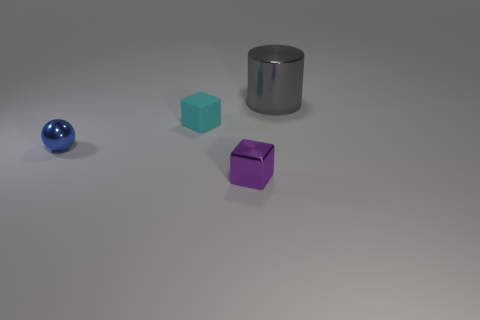Add 3 red things. How many objects exist? 7 Subtract 1 cubes. How many cubes are left? 1 Subtract all cyan cubes. How many cubes are left? 1 Subtract 0 purple spheres. How many objects are left? 4 Subtract all cylinders. How many objects are left? 3 Subtract all cyan blocks. Subtract all cyan spheres. How many blocks are left? 1 Subtract all cyan cylinders. How many cyan blocks are left? 1 Subtract all gray metallic cylinders. Subtract all small metal things. How many objects are left? 1 Add 3 large gray metal cylinders. How many large gray metal cylinders are left? 4 Add 3 tiny cyan things. How many tiny cyan things exist? 4 